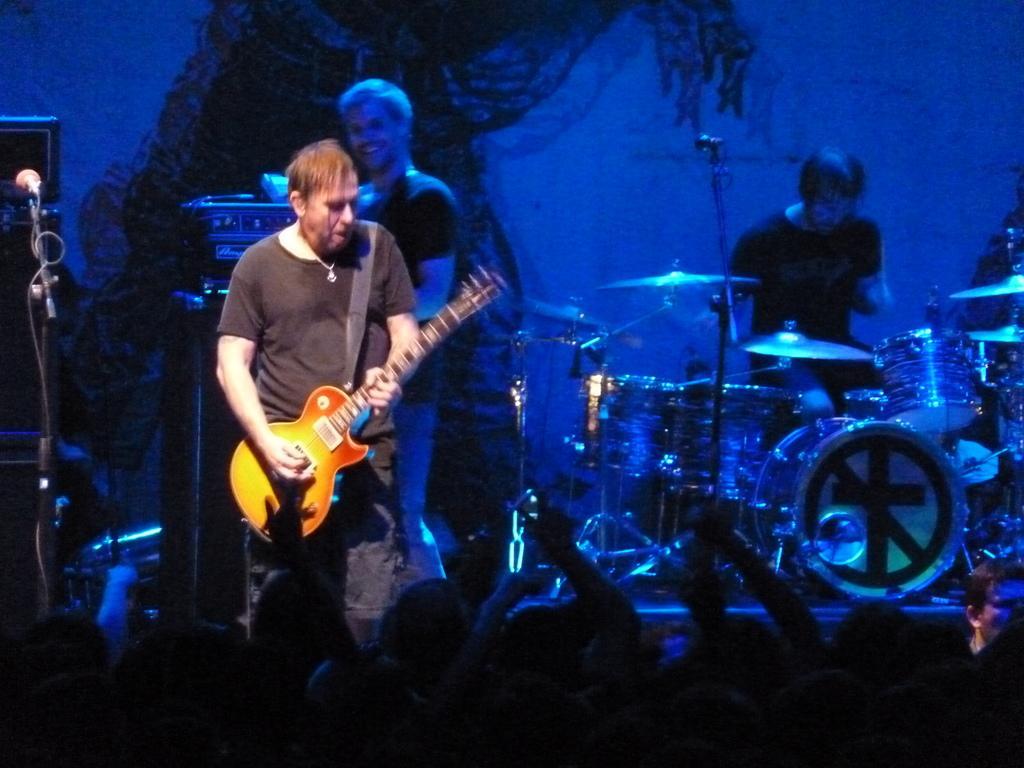Can you describe this image briefly? These two persons standing. This person holding guitar. There is a microphone with stand. This person sitting. This is musical instrument. These are audience. 